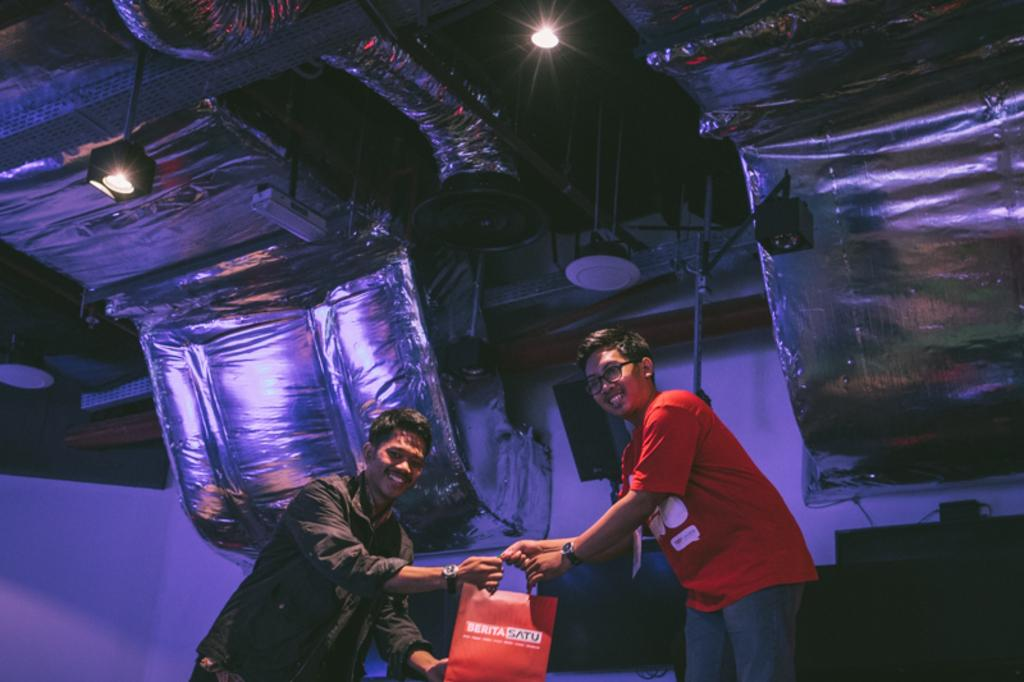How many people are in the image? There are two persons in the image. What are the persons doing in the image? The persons are standing and smiling. What are the persons holding in their hands? The persons are holding a red bag in their hands. What can be seen at the top of the image? There are lights visible at the top of the image. What is present in the background of the image? There is a wall in the image. What type of fuel is being used by the shoes in the image? There are no shoes present in the image, and therefore no fuel is being used. What color is the tooth that is visible in the image? There is no tooth visible in the image. 